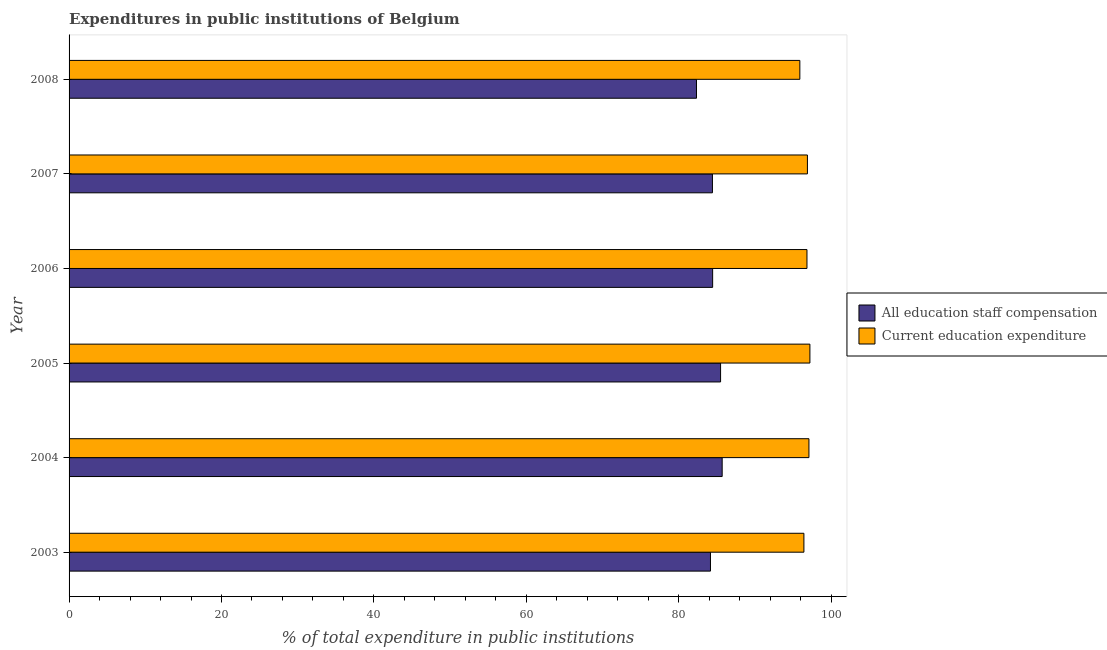How many different coloured bars are there?
Your answer should be compact. 2. What is the expenditure in education in 2006?
Keep it short and to the point. 96.82. Across all years, what is the maximum expenditure in staff compensation?
Make the answer very short. 85.7. Across all years, what is the minimum expenditure in education?
Give a very brief answer. 95.89. What is the total expenditure in staff compensation in the graph?
Provide a succinct answer. 506.53. What is the difference between the expenditure in staff compensation in 2004 and that in 2007?
Ensure brevity in your answer.  1.28. What is the difference between the expenditure in staff compensation in 2005 and the expenditure in education in 2006?
Provide a short and direct response. -11.34. What is the average expenditure in education per year?
Ensure brevity in your answer.  96.72. In the year 2008, what is the difference between the expenditure in education and expenditure in staff compensation?
Provide a succinct answer. 13.56. In how many years, is the expenditure in staff compensation greater than 40 %?
Ensure brevity in your answer.  6. What is the ratio of the expenditure in staff compensation in 2005 to that in 2008?
Make the answer very short. 1.04. Is the expenditure in education in 2004 less than that in 2008?
Your answer should be compact. No. What is the difference between the highest and the second highest expenditure in staff compensation?
Your answer should be compact. 0.21. What is the difference between the highest and the lowest expenditure in staff compensation?
Make the answer very short. 3.37. What does the 2nd bar from the top in 2006 represents?
Keep it short and to the point. All education staff compensation. What does the 1st bar from the bottom in 2005 represents?
Your answer should be compact. All education staff compensation. How many bars are there?
Your answer should be compact. 12. Are the values on the major ticks of X-axis written in scientific E-notation?
Your response must be concise. No. Does the graph contain grids?
Offer a very short reply. No. Where does the legend appear in the graph?
Keep it short and to the point. Center right. How many legend labels are there?
Your answer should be very brief. 2. How are the legend labels stacked?
Provide a short and direct response. Vertical. What is the title of the graph?
Offer a terse response. Expenditures in public institutions of Belgium. What is the label or title of the X-axis?
Provide a succinct answer. % of total expenditure in public institutions. What is the % of total expenditure in public institutions of All education staff compensation in 2003?
Make the answer very short. 84.16. What is the % of total expenditure in public institutions in Current education expenditure in 2003?
Give a very brief answer. 96.42. What is the % of total expenditure in public institutions of All education staff compensation in 2004?
Keep it short and to the point. 85.7. What is the % of total expenditure in public institutions of Current education expenditure in 2004?
Offer a very short reply. 97.08. What is the % of total expenditure in public institutions of All education staff compensation in 2005?
Offer a terse response. 85.49. What is the % of total expenditure in public institutions of Current education expenditure in 2005?
Your response must be concise. 97.21. What is the % of total expenditure in public institutions in All education staff compensation in 2006?
Provide a succinct answer. 84.45. What is the % of total expenditure in public institutions in Current education expenditure in 2006?
Offer a very short reply. 96.82. What is the % of total expenditure in public institutions in All education staff compensation in 2007?
Your answer should be very brief. 84.42. What is the % of total expenditure in public institutions of Current education expenditure in 2007?
Offer a terse response. 96.88. What is the % of total expenditure in public institutions of All education staff compensation in 2008?
Provide a short and direct response. 82.33. What is the % of total expenditure in public institutions in Current education expenditure in 2008?
Provide a short and direct response. 95.89. Across all years, what is the maximum % of total expenditure in public institutions of All education staff compensation?
Give a very brief answer. 85.7. Across all years, what is the maximum % of total expenditure in public institutions of Current education expenditure?
Offer a very short reply. 97.21. Across all years, what is the minimum % of total expenditure in public institutions of All education staff compensation?
Ensure brevity in your answer.  82.33. Across all years, what is the minimum % of total expenditure in public institutions in Current education expenditure?
Offer a terse response. 95.89. What is the total % of total expenditure in public institutions in All education staff compensation in the graph?
Your answer should be very brief. 506.53. What is the total % of total expenditure in public institutions of Current education expenditure in the graph?
Provide a short and direct response. 580.3. What is the difference between the % of total expenditure in public institutions in All education staff compensation in 2003 and that in 2004?
Provide a succinct answer. -1.53. What is the difference between the % of total expenditure in public institutions in Current education expenditure in 2003 and that in 2004?
Offer a terse response. -0.66. What is the difference between the % of total expenditure in public institutions in All education staff compensation in 2003 and that in 2005?
Keep it short and to the point. -1.33. What is the difference between the % of total expenditure in public institutions in Current education expenditure in 2003 and that in 2005?
Provide a short and direct response. -0.79. What is the difference between the % of total expenditure in public institutions in All education staff compensation in 2003 and that in 2006?
Offer a very short reply. -0.28. What is the difference between the % of total expenditure in public institutions in Current education expenditure in 2003 and that in 2006?
Your response must be concise. -0.4. What is the difference between the % of total expenditure in public institutions in All education staff compensation in 2003 and that in 2007?
Provide a short and direct response. -0.26. What is the difference between the % of total expenditure in public institutions of Current education expenditure in 2003 and that in 2007?
Offer a terse response. -0.46. What is the difference between the % of total expenditure in public institutions of All education staff compensation in 2003 and that in 2008?
Your answer should be compact. 1.83. What is the difference between the % of total expenditure in public institutions of Current education expenditure in 2003 and that in 2008?
Offer a very short reply. 0.53. What is the difference between the % of total expenditure in public institutions of All education staff compensation in 2004 and that in 2005?
Your answer should be compact. 0.21. What is the difference between the % of total expenditure in public institutions in Current education expenditure in 2004 and that in 2005?
Make the answer very short. -0.13. What is the difference between the % of total expenditure in public institutions in All education staff compensation in 2004 and that in 2006?
Ensure brevity in your answer.  1.25. What is the difference between the % of total expenditure in public institutions of Current education expenditure in 2004 and that in 2006?
Provide a succinct answer. 0.26. What is the difference between the % of total expenditure in public institutions of All education staff compensation in 2004 and that in 2007?
Your answer should be very brief. 1.28. What is the difference between the % of total expenditure in public institutions in Current education expenditure in 2004 and that in 2007?
Your answer should be very brief. 0.2. What is the difference between the % of total expenditure in public institutions of All education staff compensation in 2004 and that in 2008?
Ensure brevity in your answer.  3.37. What is the difference between the % of total expenditure in public institutions of Current education expenditure in 2004 and that in 2008?
Ensure brevity in your answer.  1.19. What is the difference between the % of total expenditure in public institutions in All education staff compensation in 2005 and that in 2006?
Provide a succinct answer. 1.04. What is the difference between the % of total expenditure in public institutions in Current education expenditure in 2005 and that in 2006?
Keep it short and to the point. 0.39. What is the difference between the % of total expenditure in public institutions of All education staff compensation in 2005 and that in 2007?
Ensure brevity in your answer.  1.07. What is the difference between the % of total expenditure in public institutions in Current education expenditure in 2005 and that in 2007?
Offer a very short reply. 0.33. What is the difference between the % of total expenditure in public institutions of All education staff compensation in 2005 and that in 2008?
Keep it short and to the point. 3.16. What is the difference between the % of total expenditure in public institutions in Current education expenditure in 2005 and that in 2008?
Your response must be concise. 1.32. What is the difference between the % of total expenditure in public institutions in All education staff compensation in 2006 and that in 2007?
Ensure brevity in your answer.  0.03. What is the difference between the % of total expenditure in public institutions of Current education expenditure in 2006 and that in 2007?
Make the answer very short. -0.06. What is the difference between the % of total expenditure in public institutions of All education staff compensation in 2006 and that in 2008?
Your answer should be compact. 2.12. What is the difference between the % of total expenditure in public institutions in Current education expenditure in 2006 and that in 2008?
Your answer should be very brief. 0.93. What is the difference between the % of total expenditure in public institutions in All education staff compensation in 2007 and that in 2008?
Give a very brief answer. 2.09. What is the difference between the % of total expenditure in public institutions in Current education expenditure in 2007 and that in 2008?
Your answer should be very brief. 0.99. What is the difference between the % of total expenditure in public institutions of All education staff compensation in 2003 and the % of total expenditure in public institutions of Current education expenditure in 2004?
Make the answer very short. -12.92. What is the difference between the % of total expenditure in public institutions in All education staff compensation in 2003 and the % of total expenditure in public institutions in Current education expenditure in 2005?
Offer a terse response. -13.05. What is the difference between the % of total expenditure in public institutions of All education staff compensation in 2003 and the % of total expenditure in public institutions of Current education expenditure in 2006?
Your answer should be very brief. -12.66. What is the difference between the % of total expenditure in public institutions of All education staff compensation in 2003 and the % of total expenditure in public institutions of Current education expenditure in 2007?
Provide a short and direct response. -12.72. What is the difference between the % of total expenditure in public institutions in All education staff compensation in 2003 and the % of total expenditure in public institutions in Current education expenditure in 2008?
Make the answer very short. -11.73. What is the difference between the % of total expenditure in public institutions in All education staff compensation in 2004 and the % of total expenditure in public institutions in Current education expenditure in 2005?
Keep it short and to the point. -11.51. What is the difference between the % of total expenditure in public institutions in All education staff compensation in 2004 and the % of total expenditure in public institutions in Current education expenditure in 2006?
Ensure brevity in your answer.  -11.13. What is the difference between the % of total expenditure in public institutions in All education staff compensation in 2004 and the % of total expenditure in public institutions in Current education expenditure in 2007?
Provide a short and direct response. -11.19. What is the difference between the % of total expenditure in public institutions of All education staff compensation in 2004 and the % of total expenditure in public institutions of Current education expenditure in 2008?
Your answer should be compact. -10.19. What is the difference between the % of total expenditure in public institutions in All education staff compensation in 2005 and the % of total expenditure in public institutions in Current education expenditure in 2006?
Your answer should be compact. -11.34. What is the difference between the % of total expenditure in public institutions in All education staff compensation in 2005 and the % of total expenditure in public institutions in Current education expenditure in 2007?
Your response must be concise. -11.4. What is the difference between the % of total expenditure in public institutions of All education staff compensation in 2005 and the % of total expenditure in public institutions of Current education expenditure in 2008?
Your answer should be compact. -10.4. What is the difference between the % of total expenditure in public institutions in All education staff compensation in 2006 and the % of total expenditure in public institutions in Current education expenditure in 2007?
Offer a terse response. -12.44. What is the difference between the % of total expenditure in public institutions of All education staff compensation in 2006 and the % of total expenditure in public institutions of Current education expenditure in 2008?
Your answer should be very brief. -11.44. What is the difference between the % of total expenditure in public institutions of All education staff compensation in 2007 and the % of total expenditure in public institutions of Current education expenditure in 2008?
Offer a terse response. -11.47. What is the average % of total expenditure in public institutions of All education staff compensation per year?
Your response must be concise. 84.42. What is the average % of total expenditure in public institutions in Current education expenditure per year?
Your response must be concise. 96.72. In the year 2003, what is the difference between the % of total expenditure in public institutions in All education staff compensation and % of total expenditure in public institutions in Current education expenditure?
Your response must be concise. -12.26. In the year 2004, what is the difference between the % of total expenditure in public institutions in All education staff compensation and % of total expenditure in public institutions in Current education expenditure?
Your response must be concise. -11.39. In the year 2005, what is the difference between the % of total expenditure in public institutions of All education staff compensation and % of total expenditure in public institutions of Current education expenditure?
Give a very brief answer. -11.72. In the year 2006, what is the difference between the % of total expenditure in public institutions of All education staff compensation and % of total expenditure in public institutions of Current education expenditure?
Offer a very short reply. -12.38. In the year 2007, what is the difference between the % of total expenditure in public institutions of All education staff compensation and % of total expenditure in public institutions of Current education expenditure?
Your answer should be compact. -12.46. In the year 2008, what is the difference between the % of total expenditure in public institutions in All education staff compensation and % of total expenditure in public institutions in Current education expenditure?
Provide a succinct answer. -13.56. What is the ratio of the % of total expenditure in public institutions of All education staff compensation in 2003 to that in 2004?
Offer a very short reply. 0.98. What is the ratio of the % of total expenditure in public institutions in All education staff compensation in 2003 to that in 2005?
Give a very brief answer. 0.98. What is the ratio of the % of total expenditure in public institutions of Current education expenditure in 2003 to that in 2006?
Make the answer very short. 1. What is the ratio of the % of total expenditure in public institutions of Current education expenditure in 2003 to that in 2007?
Your response must be concise. 1. What is the ratio of the % of total expenditure in public institutions of All education staff compensation in 2003 to that in 2008?
Keep it short and to the point. 1.02. What is the ratio of the % of total expenditure in public institutions in Current education expenditure in 2003 to that in 2008?
Offer a very short reply. 1.01. What is the ratio of the % of total expenditure in public institutions of Current education expenditure in 2004 to that in 2005?
Your response must be concise. 1. What is the ratio of the % of total expenditure in public institutions of All education staff compensation in 2004 to that in 2006?
Provide a succinct answer. 1.01. What is the ratio of the % of total expenditure in public institutions in Current education expenditure in 2004 to that in 2006?
Provide a short and direct response. 1. What is the ratio of the % of total expenditure in public institutions in All education staff compensation in 2004 to that in 2007?
Your response must be concise. 1.02. What is the ratio of the % of total expenditure in public institutions in All education staff compensation in 2004 to that in 2008?
Provide a succinct answer. 1.04. What is the ratio of the % of total expenditure in public institutions of Current education expenditure in 2004 to that in 2008?
Offer a terse response. 1.01. What is the ratio of the % of total expenditure in public institutions in All education staff compensation in 2005 to that in 2006?
Your response must be concise. 1.01. What is the ratio of the % of total expenditure in public institutions of All education staff compensation in 2005 to that in 2007?
Your answer should be compact. 1.01. What is the ratio of the % of total expenditure in public institutions of All education staff compensation in 2005 to that in 2008?
Provide a short and direct response. 1.04. What is the ratio of the % of total expenditure in public institutions in Current education expenditure in 2005 to that in 2008?
Offer a terse response. 1.01. What is the ratio of the % of total expenditure in public institutions of All education staff compensation in 2006 to that in 2008?
Offer a terse response. 1.03. What is the ratio of the % of total expenditure in public institutions of Current education expenditure in 2006 to that in 2008?
Make the answer very short. 1.01. What is the ratio of the % of total expenditure in public institutions of All education staff compensation in 2007 to that in 2008?
Offer a very short reply. 1.03. What is the ratio of the % of total expenditure in public institutions of Current education expenditure in 2007 to that in 2008?
Provide a short and direct response. 1.01. What is the difference between the highest and the second highest % of total expenditure in public institutions in All education staff compensation?
Give a very brief answer. 0.21. What is the difference between the highest and the second highest % of total expenditure in public institutions of Current education expenditure?
Provide a succinct answer. 0.13. What is the difference between the highest and the lowest % of total expenditure in public institutions of All education staff compensation?
Ensure brevity in your answer.  3.37. What is the difference between the highest and the lowest % of total expenditure in public institutions in Current education expenditure?
Make the answer very short. 1.32. 